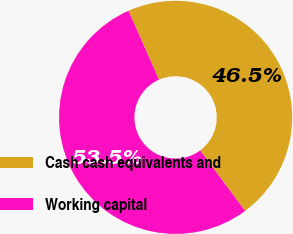Convert chart. <chart><loc_0><loc_0><loc_500><loc_500><pie_chart><fcel>Cash cash equivalents and<fcel>Working capital<nl><fcel>46.45%<fcel>53.55%<nl></chart> 